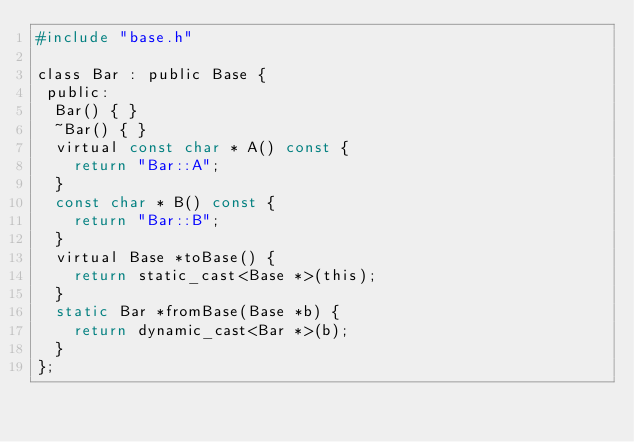<code> <loc_0><loc_0><loc_500><loc_500><_C_>#include "base.h"

class Bar : public Base {
 public:
  Bar() { }
  ~Bar() { }
  virtual const char * A() const { 
    return "Bar::A";
  }
  const char * B() const {
    return "Bar::B";
  }
  virtual Base *toBase() {
    return static_cast<Base *>(this);
  }
  static Bar *fromBase(Base *b) {
    return dynamic_cast<Bar *>(b);
  }
};


</code> 